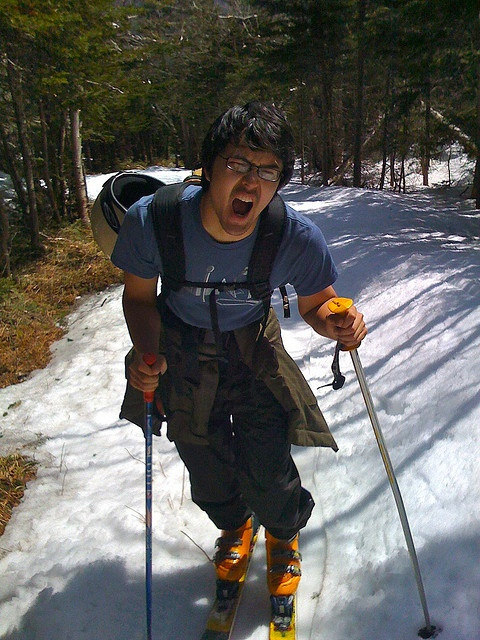Describe the objects in this image and their specific colors. I can see people in darkgreen, black, maroon, and gray tones and skis in darkgreen, black, gold, and olive tones in this image. 